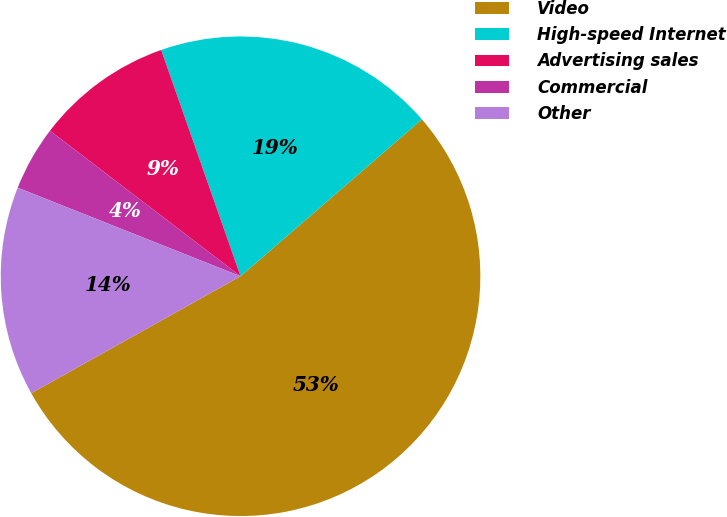Convert chart. <chart><loc_0><loc_0><loc_500><loc_500><pie_chart><fcel>Video<fcel>High-speed Internet<fcel>Advertising sales<fcel>Commercial<fcel>Other<nl><fcel>53.24%<fcel>19.02%<fcel>9.25%<fcel>4.36%<fcel>14.13%<nl></chart> 